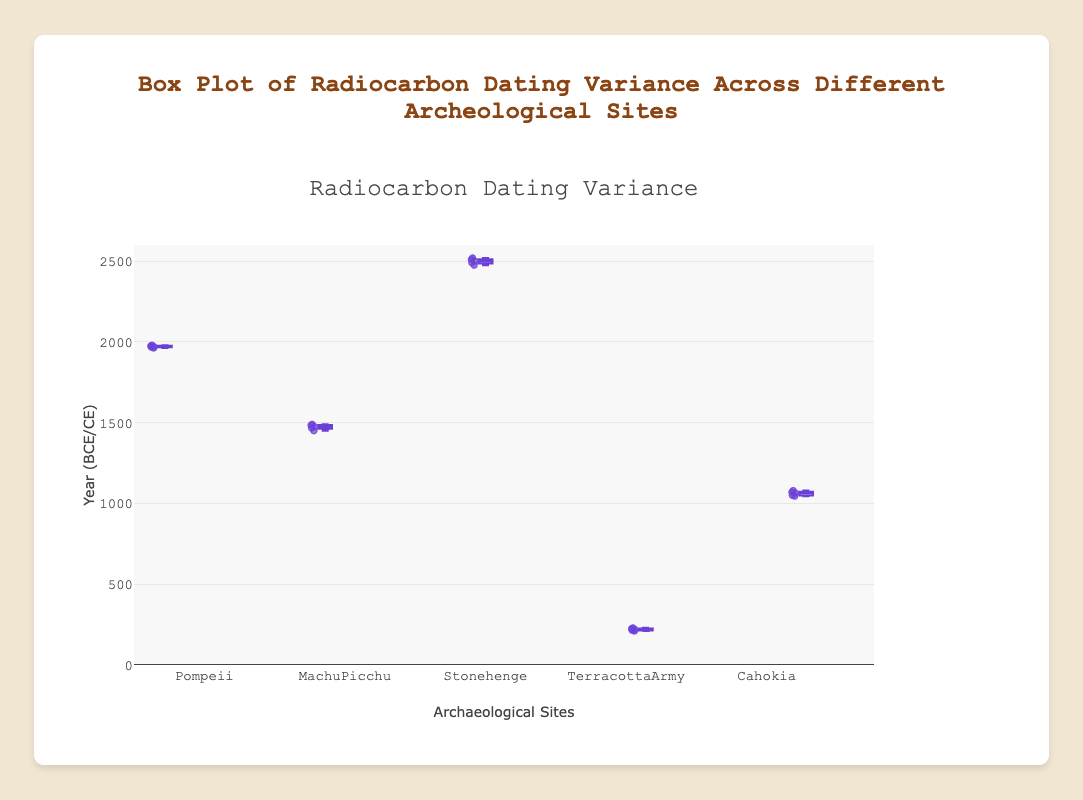What's the title of the figure? The title is displayed at the top of the figure. It reads "Box Plot of Radiocarbon Dating Variance Across Different Archeological Sites".
Answer: Box Plot of Radiocarbon Dating Variance Across Different Archeological Sites What is the range of the y-axis? The y-axis range can be seen on the left side of the plot. It starts from 0 and goes up to 2600.
Answer: 0 to 2600 Which archeological site shows the highest median radiocarbon dating value? The median can be found in the middle line of each box plot. Stonehenge has the highest median as it is around 2500.
Answer: Stonehenge What is the interquartile range (IQR) for Machu Picchu's radiocarbon dates? The IQR is the range between the first quartile (bottom of the box) and the third quartile (top of the box). For Machu Picchu, these values appear to be 1467 (Q1) and 1485 (Q3). So, the IQR is 1485 - 1467 = 18.
Answer: 18 Which site has the widest spread in data values? The site with the widest spread of data values will have the largest whiskers from the box. Stonehenge shows the widest spread, ranging approximately from 2475 to 2520.
Answer: Stonehenge What is the lowest recorded radiocarbon date for the Terracotta Army? The lowest value can be found at the end of the lower whisker. For the Terracotta Army, it is 210.
Answer: 210 How do the median dates of Pompeii and Machu Picchu compare? The median is the middle line in the box. Pompeii’s median is around 1970, while Machu Picchu’s median is around 1475. Pompeii’s median is higher than Machu Picchu’s.
Answer: Pompeii’s median is higher What is the median radiocarbon date for Cahokia? The median is represented by the line in the middle of the box. For Cahokia, the median radiocarbon date appears to be around 1065.
Answer: 1065 Which site has the smallest interquartile range in its radiocarbon dates? The interquartile range (IQR) is the range between the first quartile and the third quartile. Terracotta Army has the smallest IQR as its box is the shortest.
Answer: Terracotta Army 